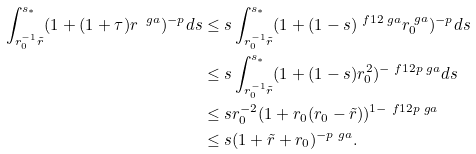<formula> <loc_0><loc_0><loc_500><loc_500>\int _ { r _ { 0 } ^ { - 1 } \tilde { r } } ^ { s _ { * } } ( 1 + ( 1 + \tau ) r ^ { \ g a } ) ^ { - p } d s & \leq s \int ^ { s _ { * } } _ { r _ { 0 } ^ { - 1 } \tilde { r } } ( 1 + ( 1 - s ) ^ { \ f 1 2 \ g a } r _ { 0 } ^ { \ g a } ) ^ { - p } d s \\ & \leq s \int ^ { s _ { * } } _ { r _ { 0 } ^ { - 1 } \tilde { r } } ( 1 + ( 1 - s ) r _ { 0 } ^ { 2 } ) ^ { - \ f 1 2 p \ g a } d s \\ & \leq s r _ { 0 } ^ { - 2 } ( 1 + r _ { 0 } ( r _ { 0 } - \tilde { r } ) ) ^ { 1 - \ f 1 2 p \ g a } \\ & \leq s ( 1 + \tilde { r } + r _ { 0 } ) ^ { - p \ g a } .</formula> 